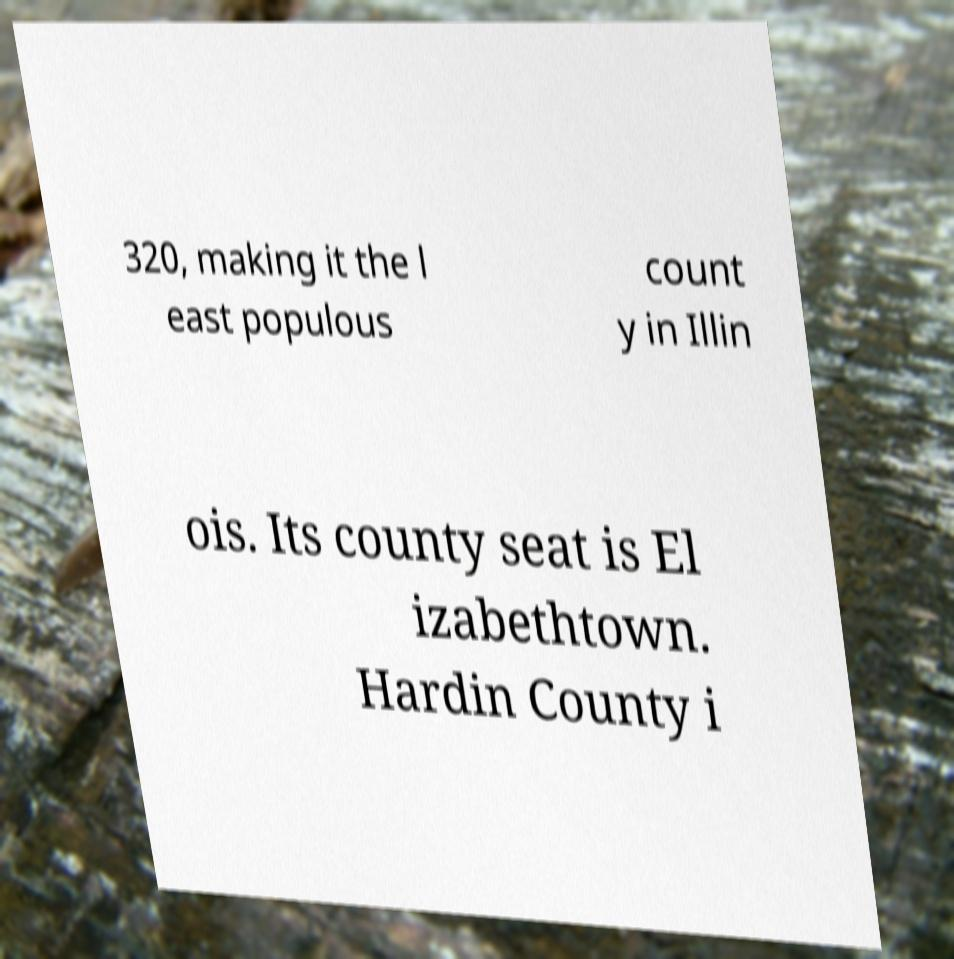Can you read and provide the text displayed in the image?This photo seems to have some interesting text. Can you extract and type it out for me? 320, making it the l east populous count y in Illin ois. Its county seat is El izabethtown. Hardin County i 